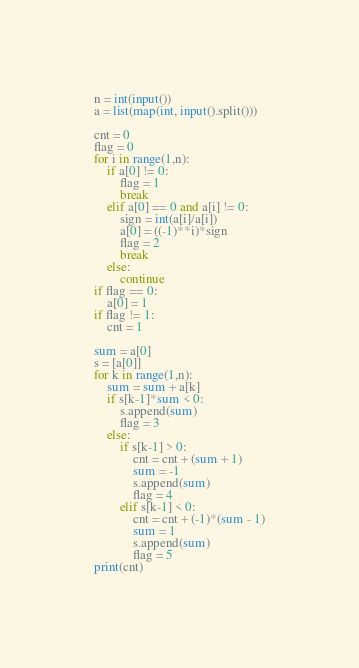<code> <loc_0><loc_0><loc_500><loc_500><_Python_>n = int(input())
a = list(map(int, input().split()))

cnt = 0
flag = 0
for i in range(1,n):
    if a[0] != 0:
        flag = 1
        break
    elif a[0] == 0 and a[i] != 0:
        sign = int(a[i]/a[i])
        a[0] = ((-1)**i)*sign
        flag = 2
        break
    else:
        continue
if flag == 0:
    a[0] = 1
if flag != 1:
    cnt = 1

sum = a[0]
s = [a[0]]
for k in range(1,n):
    sum = sum + a[k]
    if s[k-1]*sum < 0:
        s.append(sum)
        flag = 3
    else:
        if s[k-1] > 0:
            cnt = cnt + (sum + 1)
            sum = -1
            s.append(sum)
            flag = 4
        elif s[k-1] < 0:
            cnt = cnt + (-1)*(sum - 1)
            sum = 1
            s.append(sum)
            flag = 5
print(cnt)</code> 